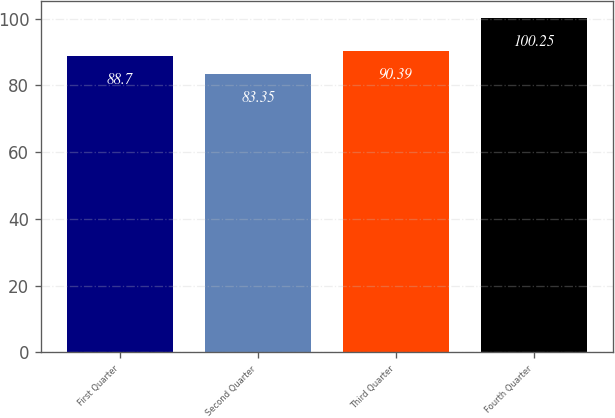Convert chart to OTSL. <chart><loc_0><loc_0><loc_500><loc_500><bar_chart><fcel>First Quarter<fcel>Second Quarter<fcel>Third Quarter<fcel>Fourth Quarter<nl><fcel>88.7<fcel>83.35<fcel>90.39<fcel>100.25<nl></chart> 